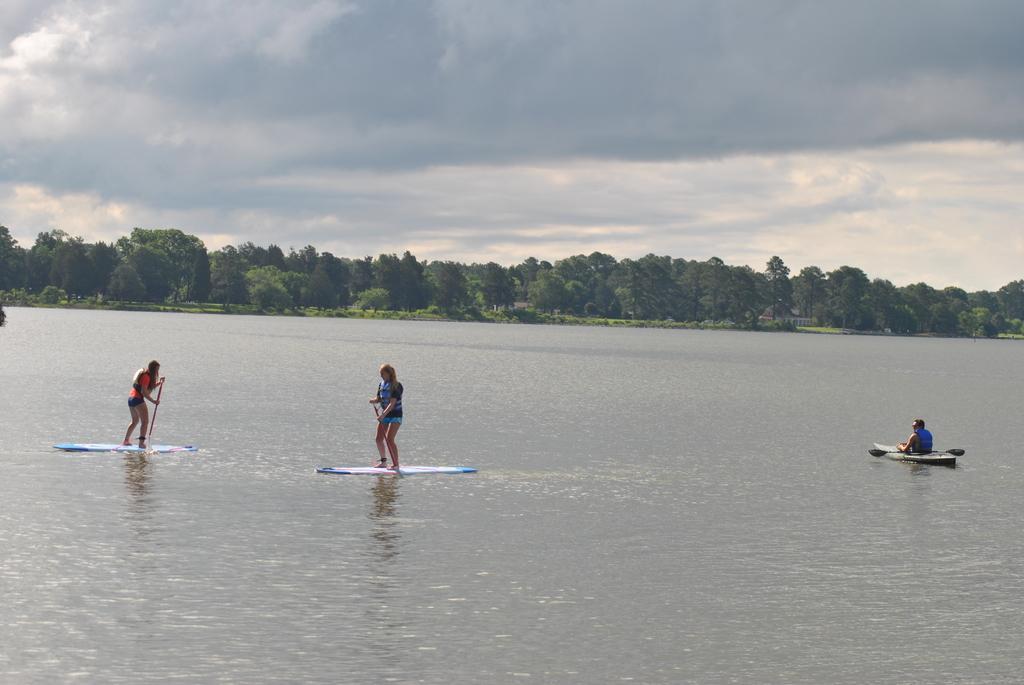Describe this image in one or two sentences. In this image we can see a person rowing a boat on the water and two persons standing on the surfboard and in the background there are few trees and the sky with clouds. 